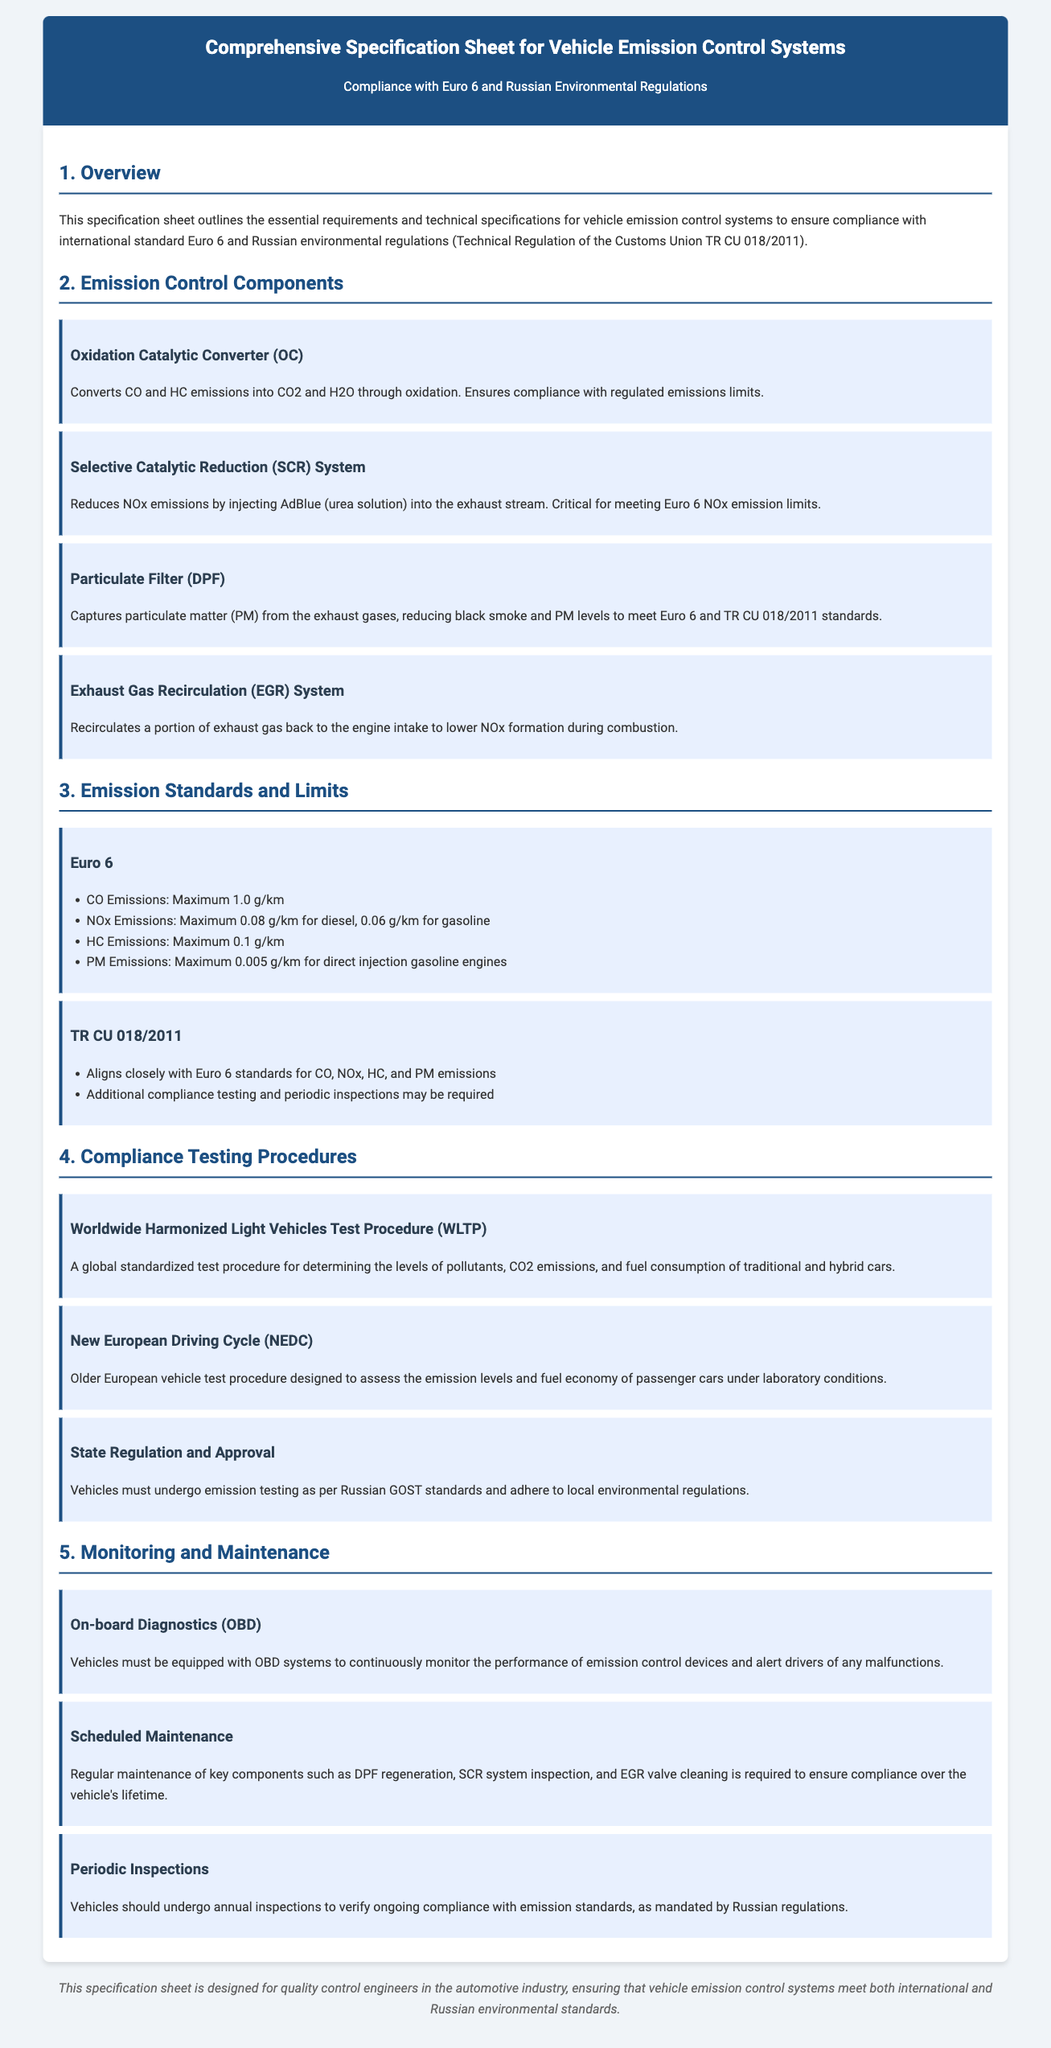What is the maximum CO emissions allowed under Euro 6? The maximum CO emissions are specified in the standards listed in the document. According to Euro 6, the limit is 1.0 g/km.
Answer: 1.0 g/km What does SCR stand for in emission control systems? The acronym SCR refers to a specific emission control technology mentioned in the document used to reduce NOx emissions.
Answer: Selective Catalytic Reduction What is the primary function of a Particulate Filter (DPF)? The document explains the function of the DPF in detail, stating that it captures particulate matter from exhaust gases.
Answer: Captures particulate matter What is the primary regulation that aligns closely with Euro 6 standards in Russia? The document mentions a specific regulation that governs emissions in Russia, emphasizing its alignment with Euro 6.
Answer: TR CU 018/2011 What testing procedure is abbreviated as WLTP? The document describes this testing procedure aimed at measuring pollutant levels, CO2 emissions, and fuel consumption.
Answer: Worldwide Harmonized Light Vehicles Test Procedure How often should vehicles undergo periodic inspections according to Russian regulations? The document specifies the frequency of inspections required to ensure compliance with emission standards.
Answer: Annually What component monitors the performance of emission control devices? The document mentions a system that is essential for ongoing monitoring and malfunction alerts in vehicles.
Answer: On-board Diagnostics (OBD) What is the maximum NOx emissions for gasoline vehicles under Euro 6? The document outlines the specific emission limits for different vehicle types under Euro 6, including gasoline.
Answer: 0.06 g/km 